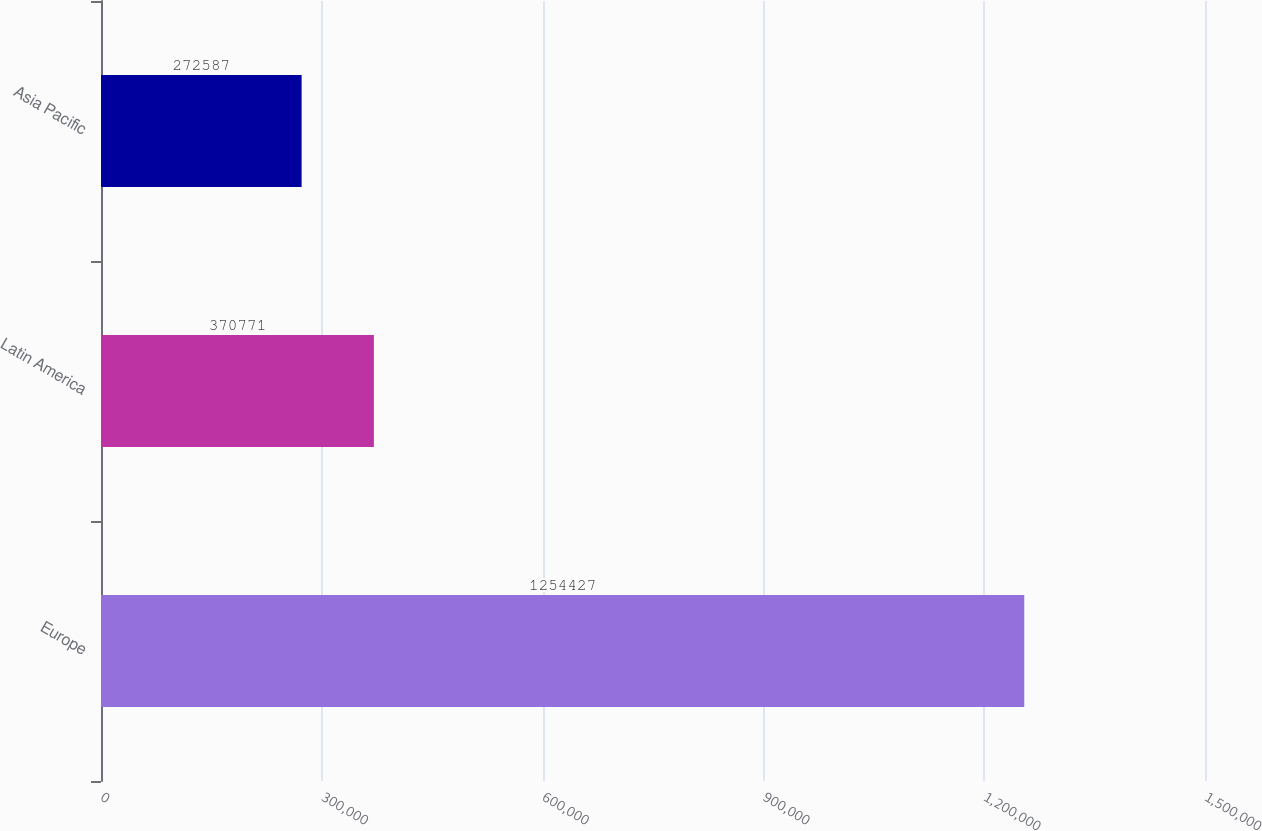Convert chart. <chart><loc_0><loc_0><loc_500><loc_500><bar_chart><fcel>Europe<fcel>Latin America<fcel>Asia Pacific<nl><fcel>1.25443e+06<fcel>370771<fcel>272587<nl></chart> 